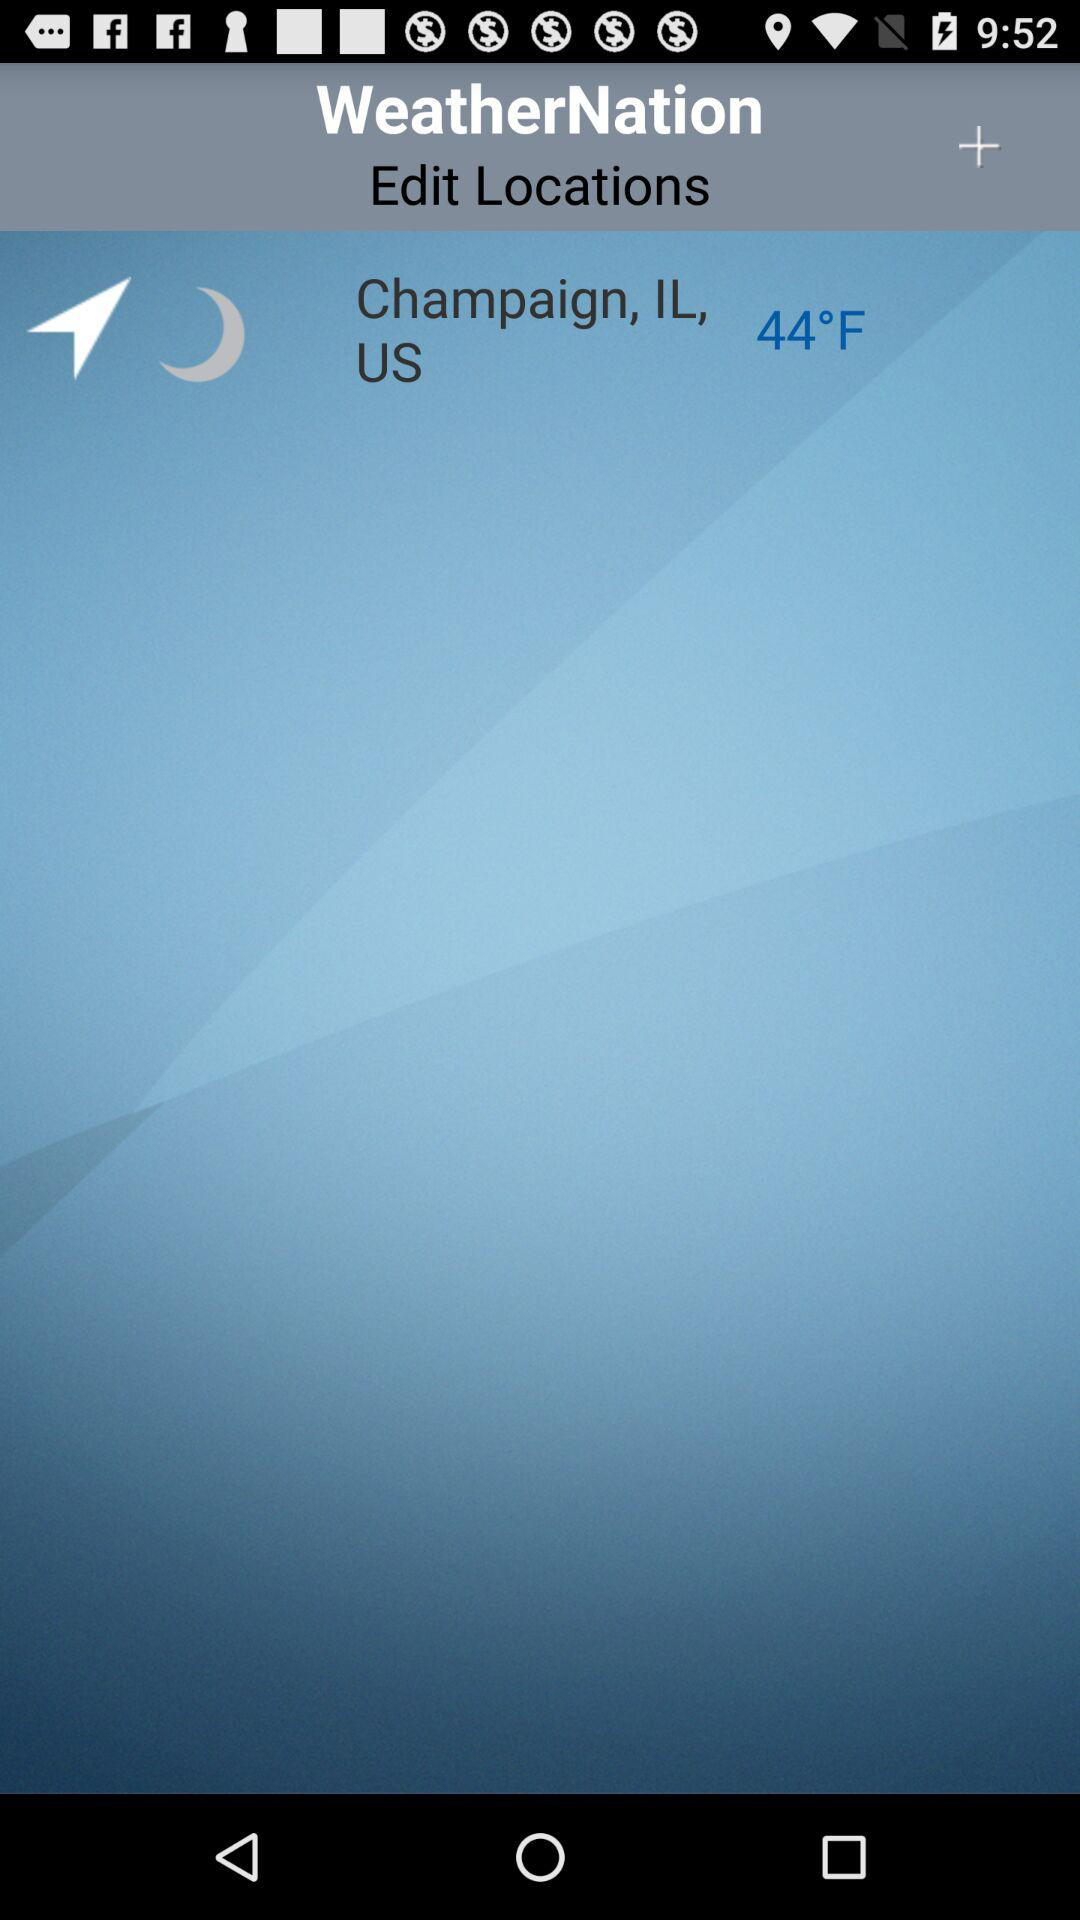What is the temperature in Champaign, IL, US? The temperature is 44 degrees Fahrenheit. 